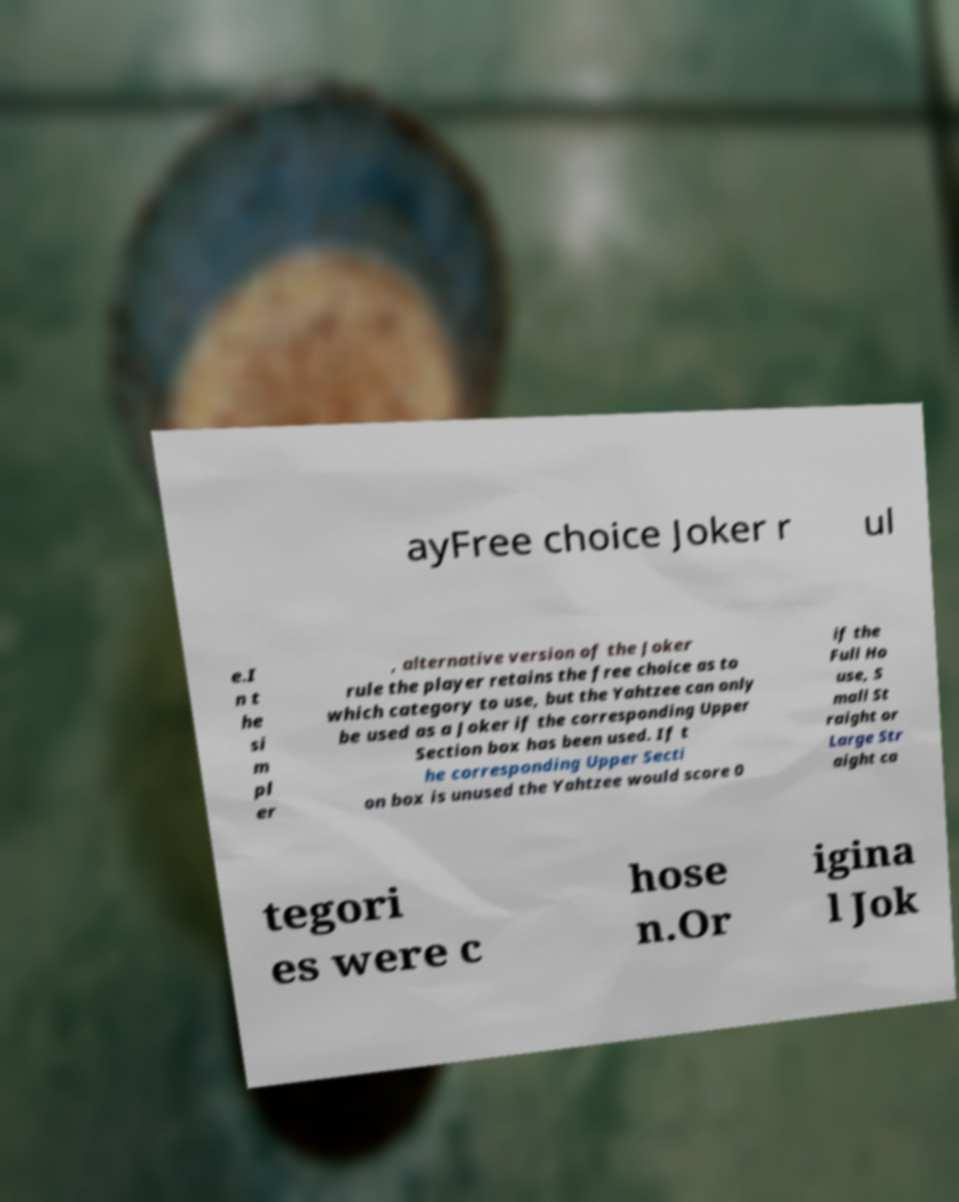Can you accurately transcribe the text from the provided image for me? ayFree choice Joker r ul e.I n t he si m pl er , alternative version of the Joker rule the player retains the free choice as to which category to use, but the Yahtzee can only be used as a Joker if the corresponding Upper Section box has been used. If t he corresponding Upper Secti on box is unused the Yahtzee would score 0 if the Full Ho use, S mall St raight or Large Str aight ca tegori es were c hose n.Or igina l Jok 